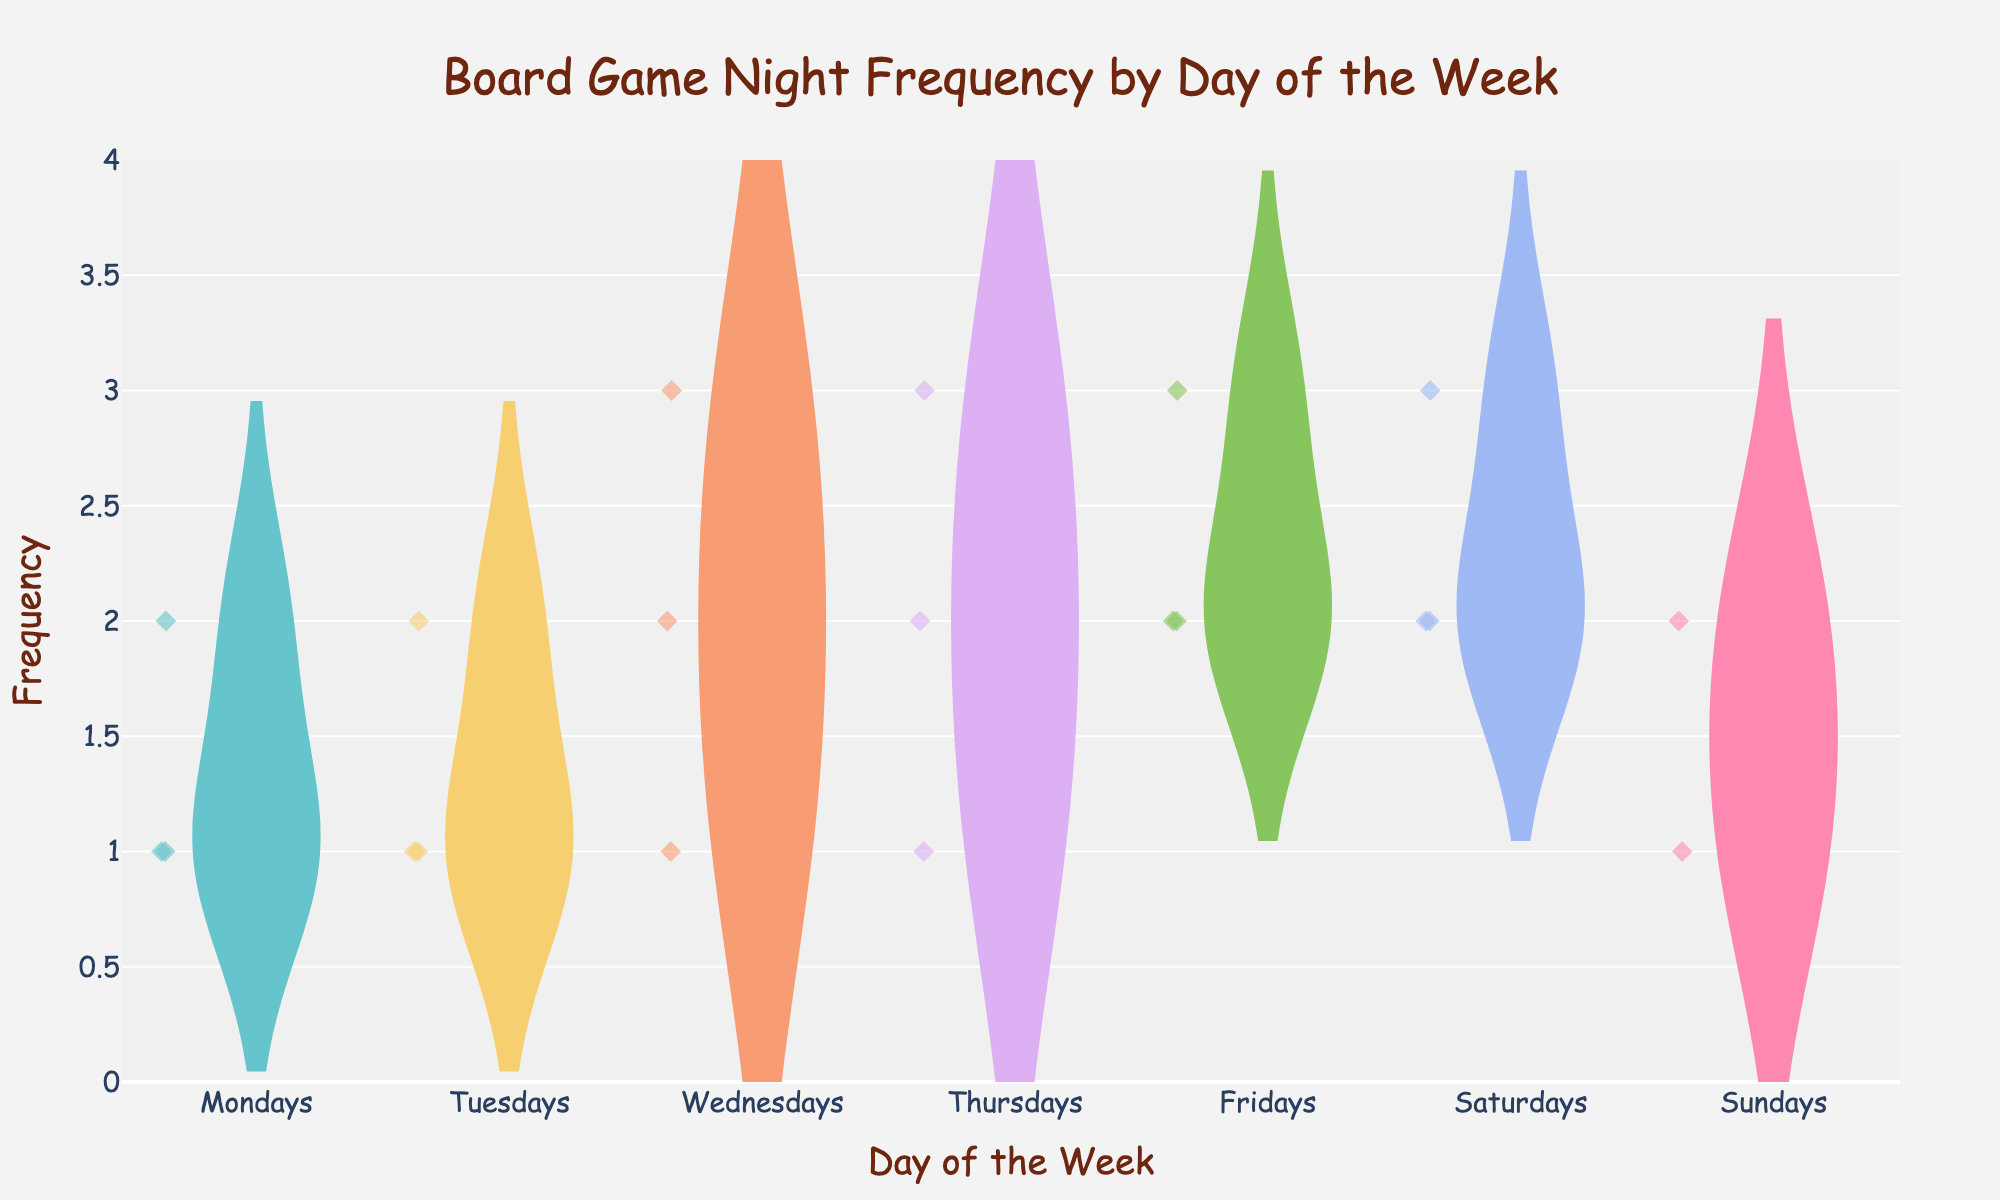What's the title of the figure? Look at the top of the figure; the title should be written there, summarizing what the plot shows.
Answer: Board Game Night Frequency by Day of the Week What does the x-axis represent? Examine the label near the x-axis; it indicates what the x-axis represents.
Answer: Day of the Week What is the range of the y-axis? Look at the minimum and maximum values indicated on the y-axis.
Answer: 0 to 4 On which day is the maximum frequency of board game nights the highest? Look at the violin plots for each day and compare their upper ends to see which one extends the highest.
Answer: Saturdays Which day has the lowest overall frequency of board game nights? Check the violin plots, note which day has the lowest spread of data points, and compare the minimum values.
Answer: Mondays What is the median frequency of board game nights on Fridays? Find the line within the box of the Friday violin plot, which indicates the median value.
Answer: 2 How does the average frequency of board game nights on Wednesdays compare to Fridays? Identify the mean lines in the Wednesday and Friday violin plots and compare their positions on the y-axis.
Answer: Equal (both are 2) What's the difference between the highest frequency on Thursdays and the highest frequency on Tuesdays? Check the maximum point of the violin plot for Thursdays (3) and Tuesdays (2), then subtract the smaller from the larger.
Answer: 1 How evenly are the board game nights spread throughout the week in terms of frequency? Look at the spread and distribution of frequencies across all days' violin plots to gauge evenness.
Answer: Fairly even, with slight variations 